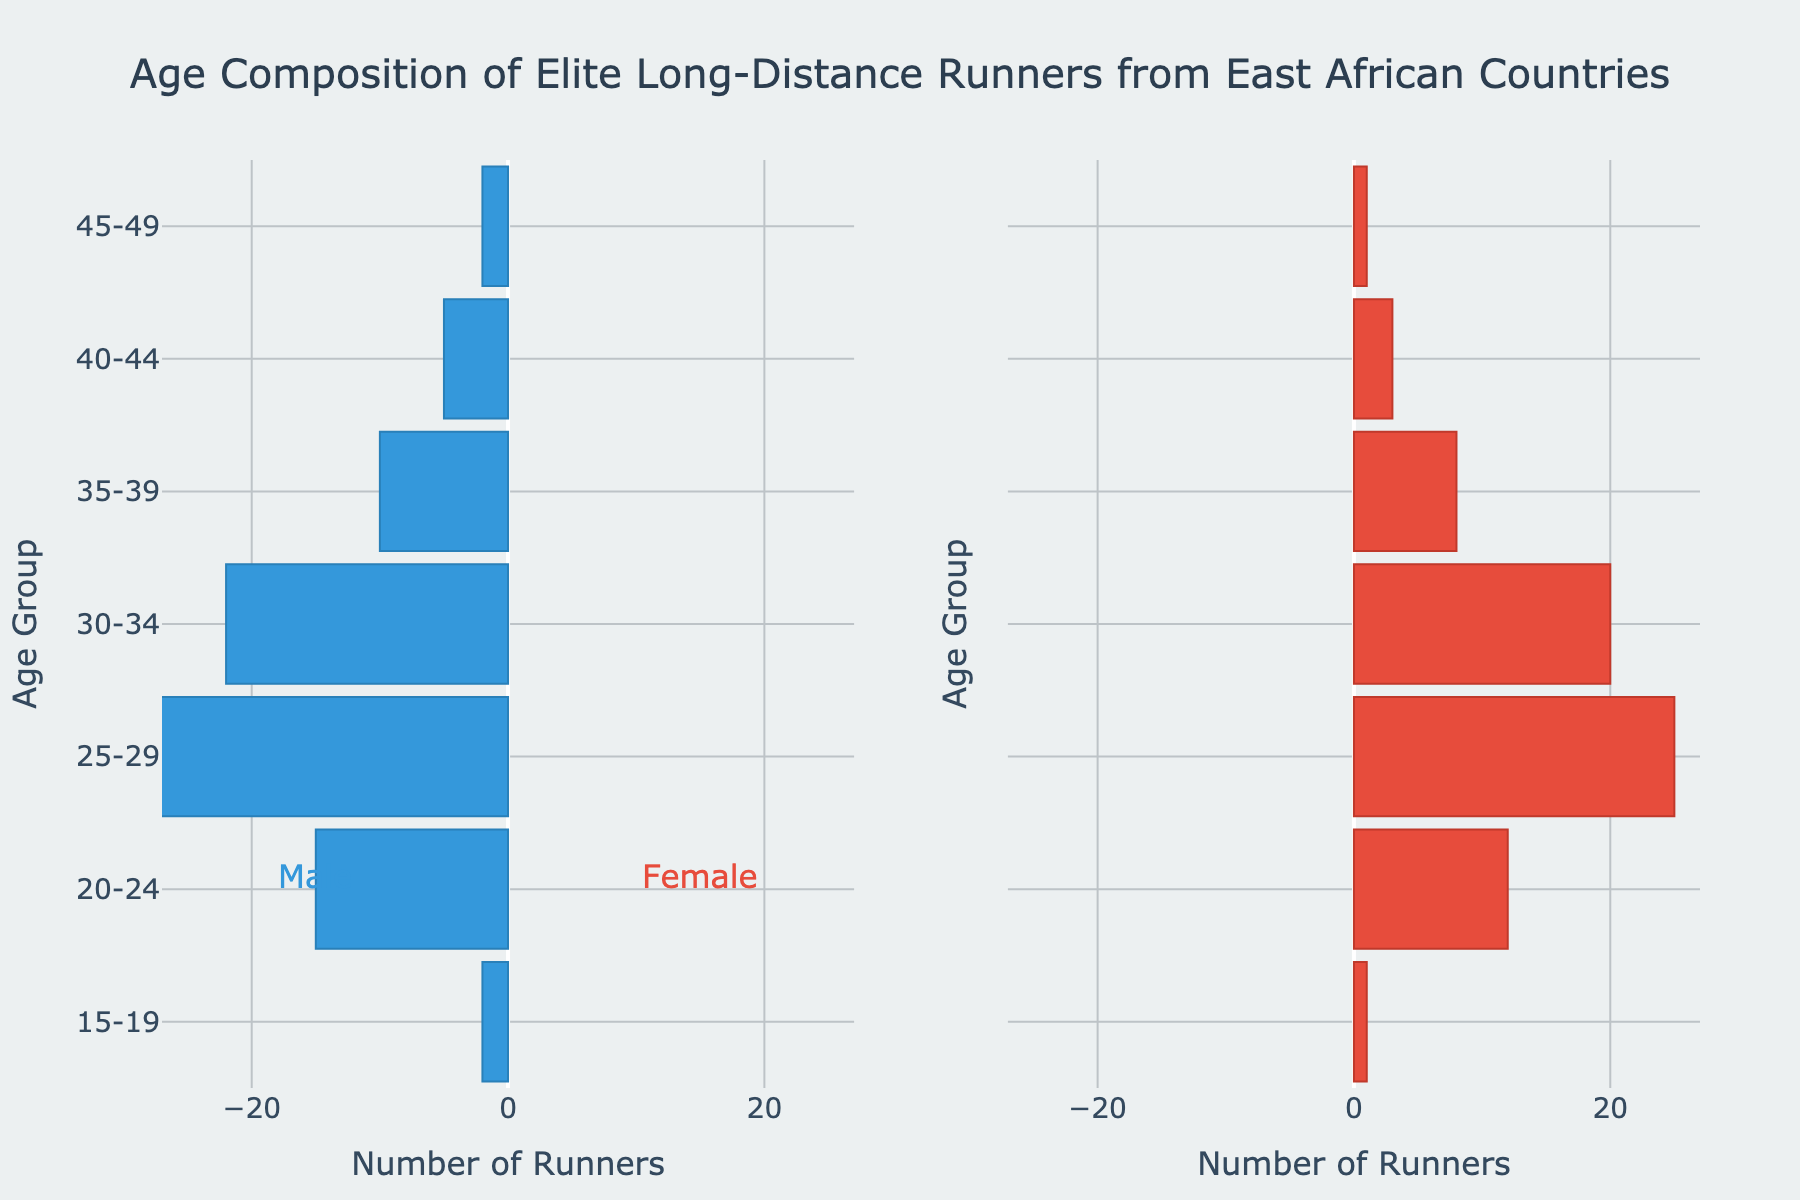What's the title of the figure? The title is typically located at the top of the figure and summarizes the entire chart. In this case, it reads "Age Composition of Elite Long-Distance Runners from East African Countries".
Answer: Age Composition of Elite Long-Distance Runners from East African Countries What age group has the highest number of male runners? Look at the male bars and identify the one that extends the farthest to the left. The data shows that the "25-29" age group has the longest male bar, indicating it has the highest number.
Answer: 25-29 How many female runners are in the 30-34 age group? Locate the "30-34" age group on the y-axis and find the corresponding female bar. Count the value by the length of the bar. The bar for the female runners in the 30-34 age group is at "20".
Answer: 20 What is the total number of runners in the 20-24 age group? Add the number of male and female runners in the 20-24 age group. According to the figure, there are 15 male and 12 female runners: 15 + 12 = 27.
Answer: 27 Which gender has more runners in the 35-39 age group? Compare the lengths of the male and female bars for the 35-39 age group. The male bar is longer (10) compared to the female bar (8).
Answer: Male What is the combined number of runners in the 45-49 age group? Add the number of male and female runners: 2 male + 1 female = 3.
Answer: 3 Which age group has the smallest number of female runners? Look at all the age groups and find the shortest female bar. The "15-19" and "45-49" groups have the shortest bars, with 1 female runner each.
Answer: 15-19 and 45-49 What is the age group range with the most runners for both genders combined? Sum the number of male and female runners for each age group and compare the totals. The "25-29" age group has the highest combined number of runners (28 male + 25 female = 53).
Answer: 25-29 Are there more male or female runners overall? Sum all the male and female runners across all age groups and compare. Male runners: 2 + 15 + 28 + 22 + 10 + 5 + 2 = 84. Female runners: 1 + 12 + 25 + 20 + 8 + 3 + 1 = 70. There are more male runners overall.
Answer: Male What is the average number of runners in the 40-44 age group for both genders? Add the male and female runners in the 40-44 age group, then divide by 2: (5 male + 3 female) / 2 = 8 / 2 = 4.
Answer: 4 